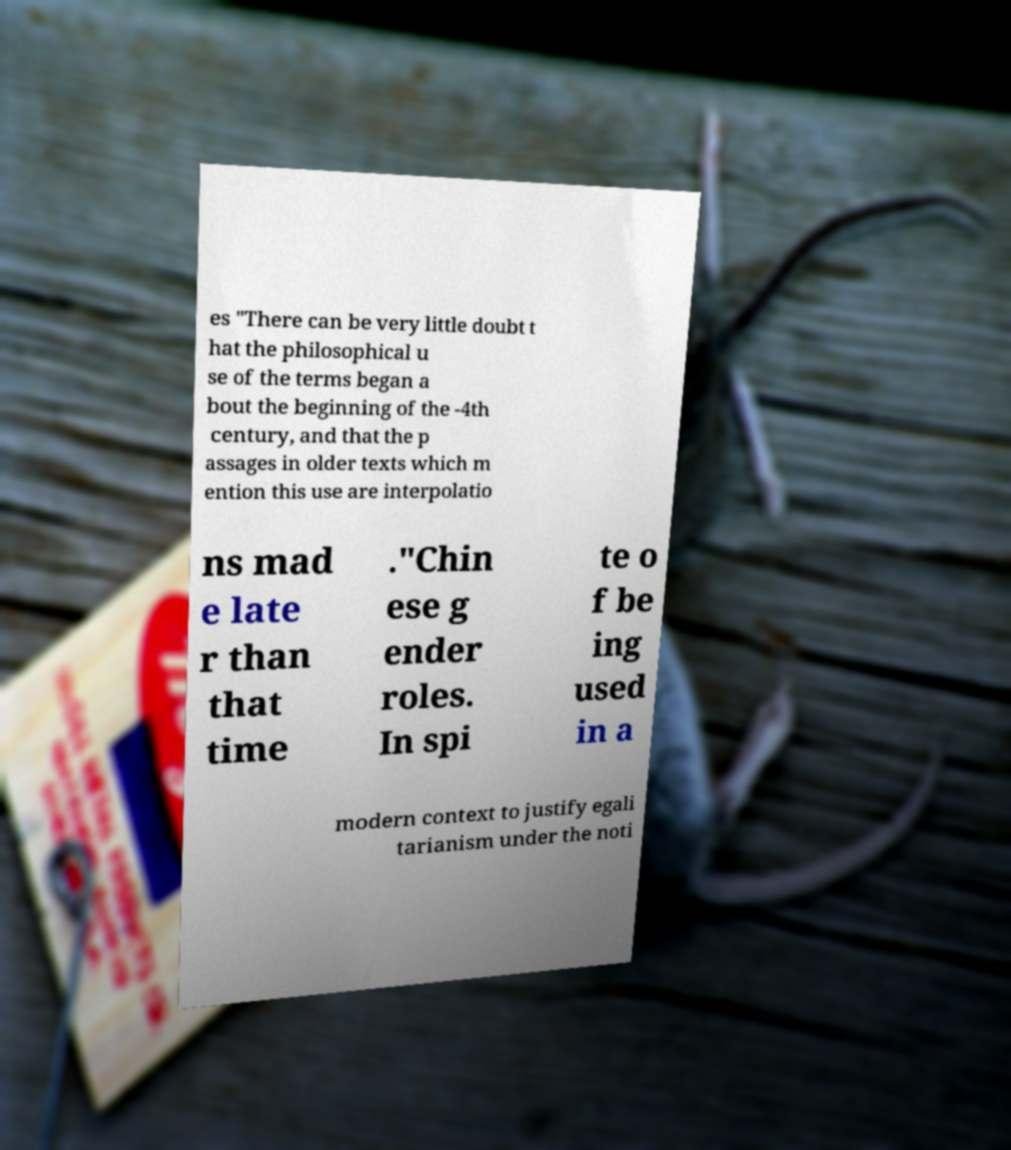There's text embedded in this image that I need extracted. Can you transcribe it verbatim? es "There can be very little doubt t hat the philosophical u se of the terms began a bout the beginning of the -4th century, and that the p assages in older texts which m ention this use are interpolatio ns mad e late r than that time ."Chin ese g ender roles. In spi te o f be ing used in a modern context to justify egali tarianism under the noti 